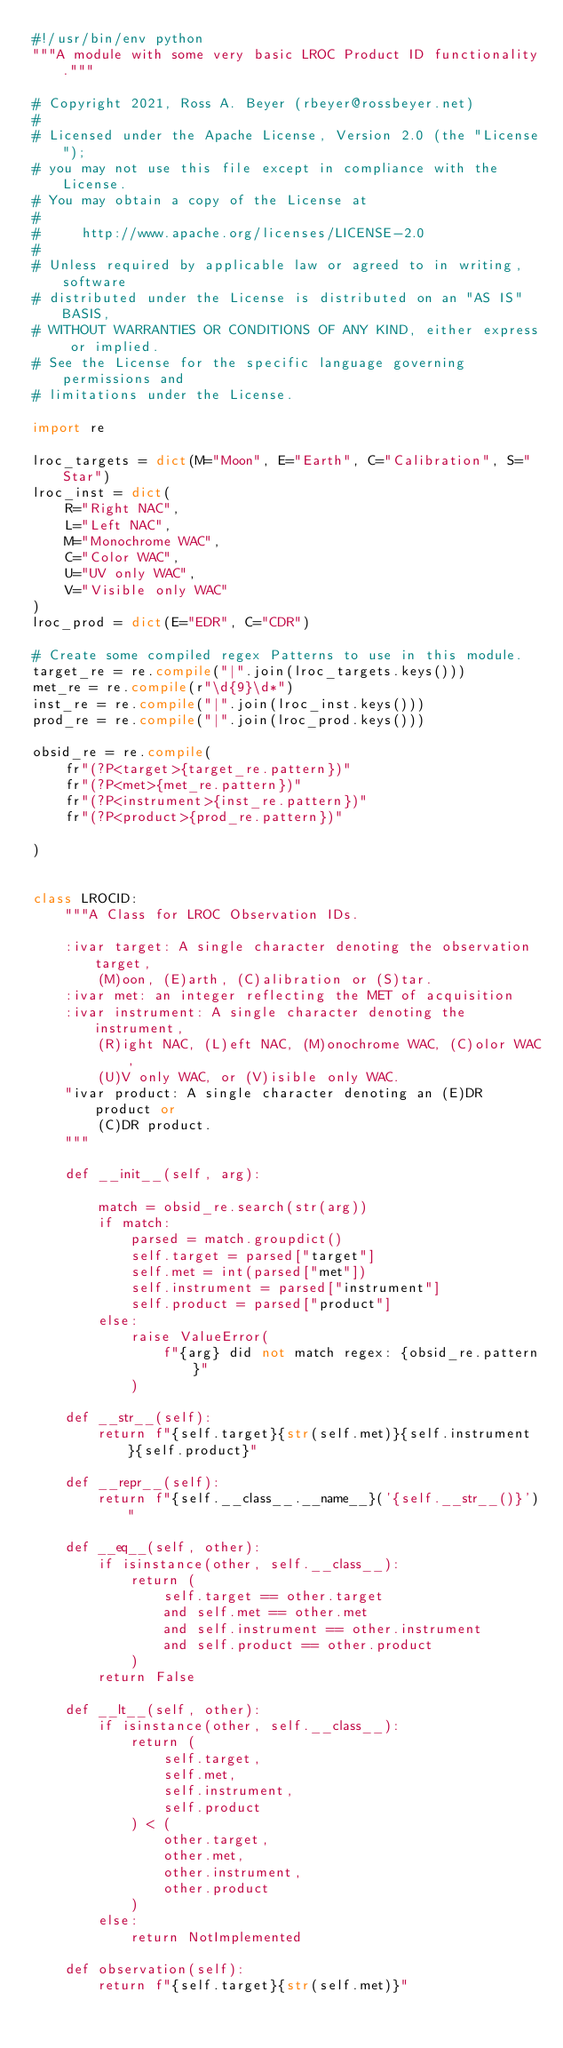Convert code to text. <code><loc_0><loc_0><loc_500><loc_500><_Python_>#!/usr/bin/env python
"""A module with some very basic LROC Product ID functionality."""

# Copyright 2021, Ross A. Beyer (rbeyer@rossbeyer.net)
#
# Licensed under the Apache License, Version 2.0 (the "License");
# you may not use this file except in compliance with the License.
# You may obtain a copy of the License at
#
#     http://www.apache.org/licenses/LICENSE-2.0
#
# Unless required by applicable law or agreed to in writing, software
# distributed under the License is distributed on an "AS IS" BASIS,
# WITHOUT WARRANTIES OR CONDITIONS OF ANY KIND, either express or implied.
# See the License for the specific language governing permissions and
# limitations under the License.

import re

lroc_targets = dict(M="Moon", E="Earth", C="Calibration", S="Star")
lroc_inst = dict(
    R="Right NAC",
    L="Left NAC",
    M="Monochrome WAC",
    C="Color WAC",
    U="UV only WAC",
    V="Visible only WAC"
)
lroc_prod = dict(E="EDR", C="CDR")

# Create some compiled regex Patterns to use in this module.
target_re = re.compile("|".join(lroc_targets.keys()))
met_re = re.compile(r"\d{9}\d*")
inst_re = re.compile("|".join(lroc_inst.keys()))
prod_re = re.compile("|".join(lroc_prod.keys()))

obsid_re = re.compile(
    fr"(?P<target>{target_re.pattern})"
    fr"(?P<met>{met_re.pattern})"
    fr"(?P<instrument>{inst_re.pattern})"
    fr"(?P<product>{prod_re.pattern})"

)


class LROCID:
    """A Class for LROC Observation IDs.

    :ivar target: A single character denoting the observation target,
        (M)oon, (E)arth, (C)alibration or (S)tar.
    :ivar met: an integer reflecting the MET of acquisition
    :ivar instrument: A single character denoting the instrument,
        (R)ight NAC, (L)eft NAC, (M)onochrome WAC, (C)olor WAC,
        (U)V only WAC, or (V)isible only WAC.
    "ivar product: A single character denoting an (E)DR product or
        (C)DR product.
    """

    def __init__(self, arg):

        match = obsid_re.search(str(arg))
        if match:
            parsed = match.groupdict()
            self.target = parsed["target"]
            self.met = int(parsed["met"])
            self.instrument = parsed["instrument"]
            self.product = parsed["product"]
        else:
            raise ValueError(
                f"{arg} did not match regex: {obsid_re.pattern}"
            )

    def __str__(self):
        return f"{self.target}{str(self.met)}{self.instrument}{self.product}"

    def __repr__(self):
        return f"{self.__class__.__name__}('{self.__str__()}')"

    def __eq__(self, other):
        if isinstance(other, self.__class__):
            return (
                self.target == other.target
                and self.met == other.met
                and self.instrument == other.instrument
                and self.product == other.product
            )
        return False

    def __lt__(self, other):
        if isinstance(other, self.__class__):
            return (
                self.target,
                self.met,
                self.instrument,
                self.product
            ) < (
                other.target,
                other.met,
                other.instrument,
                other.product
            )
        else:
            return NotImplemented

    def observation(self):
        return f"{self.target}{str(self.met)}"
</code> 